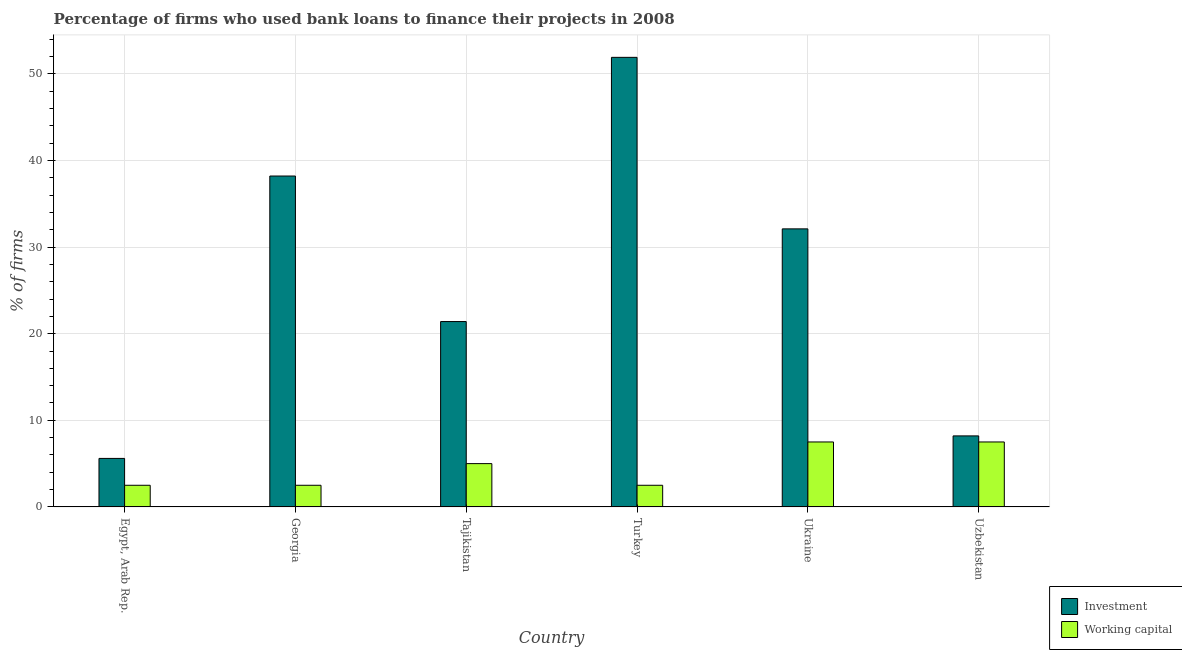What is the label of the 3rd group of bars from the left?
Offer a terse response. Tajikistan. What is the percentage of firms using banks to finance investment in Ukraine?
Your answer should be compact. 32.1. Across all countries, what is the maximum percentage of firms using banks to finance investment?
Give a very brief answer. 51.9. In which country was the percentage of firms using banks to finance working capital maximum?
Offer a very short reply. Ukraine. In which country was the percentage of firms using banks to finance working capital minimum?
Make the answer very short. Egypt, Arab Rep. What is the difference between the percentage of firms using banks to finance investment in Ukraine and that in Uzbekistan?
Your answer should be very brief. 23.9. What is the difference between the percentage of firms using banks to finance working capital in Tajikistan and the percentage of firms using banks to finance investment in Turkey?
Offer a terse response. -46.9. What is the average percentage of firms using banks to finance working capital per country?
Keep it short and to the point. 4.58. What is the difference between the percentage of firms using banks to finance investment and percentage of firms using banks to finance working capital in Uzbekistan?
Keep it short and to the point. 0.7. In how many countries, is the percentage of firms using banks to finance investment greater than 28 %?
Ensure brevity in your answer.  3. What is the difference between the highest and the second highest percentage of firms using banks to finance investment?
Give a very brief answer. 13.7. In how many countries, is the percentage of firms using banks to finance investment greater than the average percentage of firms using banks to finance investment taken over all countries?
Your response must be concise. 3. Is the sum of the percentage of firms using banks to finance working capital in Egypt, Arab Rep. and Turkey greater than the maximum percentage of firms using banks to finance investment across all countries?
Offer a terse response. No. What does the 2nd bar from the left in Uzbekistan represents?
Provide a succinct answer. Working capital. What does the 2nd bar from the right in Uzbekistan represents?
Ensure brevity in your answer.  Investment. Are all the bars in the graph horizontal?
Provide a succinct answer. No. Does the graph contain any zero values?
Make the answer very short. No. How many legend labels are there?
Make the answer very short. 2. What is the title of the graph?
Your response must be concise. Percentage of firms who used bank loans to finance their projects in 2008. Does "Female labourers" appear as one of the legend labels in the graph?
Ensure brevity in your answer.  No. What is the label or title of the X-axis?
Provide a short and direct response. Country. What is the label or title of the Y-axis?
Keep it short and to the point. % of firms. What is the % of firms in Investment in Egypt, Arab Rep.?
Give a very brief answer. 5.6. What is the % of firms in Investment in Georgia?
Your answer should be compact. 38.2. What is the % of firms in Investment in Tajikistan?
Your answer should be compact. 21.4. What is the % of firms in Investment in Turkey?
Ensure brevity in your answer.  51.9. What is the % of firms in Investment in Ukraine?
Offer a very short reply. 32.1. What is the % of firms of Working capital in Uzbekistan?
Provide a succinct answer. 7.5. Across all countries, what is the maximum % of firms in Investment?
Make the answer very short. 51.9. Across all countries, what is the minimum % of firms of Working capital?
Your answer should be compact. 2.5. What is the total % of firms of Investment in the graph?
Your answer should be compact. 157.4. What is the difference between the % of firms of Investment in Egypt, Arab Rep. and that in Georgia?
Your answer should be very brief. -32.6. What is the difference between the % of firms of Working capital in Egypt, Arab Rep. and that in Georgia?
Provide a succinct answer. 0. What is the difference between the % of firms of Investment in Egypt, Arab Rep. and that in Tajikistan?
Give a very brief answer. -15.8. What is the difference between the % of firms of Investment in Egypt, Arab Rep. and that in Turkey?
Give a very brief answer. -46.3. What is the difference between the % of firms in Investment in Egypt, Arab Rep. and that in Ukraine?
Give a very brief answer. -26.5. What is the difference between the % of firms of Working capital in Egypt, Arab Rep. and that in Ukraine?
Keep it short and to the point. -5. What is the difference between the % of firms of Working capital in Georgia and that in Tajikistan?
Offer a very short reply. -2.5. What is the difference between the % of firms in Investment in Georgia and that in Turkey?
Offer a very short reply. -13.7. What is the difference between the % of firms of Working capital in Georgia and that in Turkey?
Your answer should be compact. 0. What is the difference between the % of firms in Investment in Georgia and that in Ukraine?
Your answer should be compact. 6.1. What is the difference between the % of firms in Working capital in Georgia and that in Ukraine?
Offer a very short reply. -5. What is the difference between the % of firms of Investment in Georgia and that in Uzbekistan?
Give a very brief answer. 30. What is the difference between the % of firms in Investment in Tajikistan and that in Turkey?
Offer a terse response. -30.5. What is the difference between the % of firms of Working capital in Tajikistan and that in Turkey?
Ensure brevity in your answer.  2.5. What is the difference between the % of firms of Investment in Tajikistan and that in Ukraine?
Make the answer very short. -10.7. What is the difference between the % of firms of Working capital in Tajikistan and that in Uzbekistan?
Provide a succinct answer. -2.5. What is the difference between the % of firms of Investment in Turkey and that in Ukraine?
Your response must be concise. 19.8. What is the difference between the % of firms of Working capital in Turkey and that in Ukraine?
Your answer should be compact. -5. What is the difference between the % of firms in Investment in Turkey and that in Uzbekistan?
Keep it short and to the point. 43.7. What is the difference between the % of firms of Working capital in Turkey and that in Uzbekistan?
Your answer should be compact. -5. What is the difference between the % of firms in Investment in Ukraine and that in Uzbekistan?
Keep it short and to the point. 23.9. What is the difference between the % of firms in Investment in Egypt, Arab Rep. and the % of firms in Working capital in Georgia?
Offer a terse response. 3.1. What is the difference between the % of firms in Investment in Egypt, Arab Rep. and the % of firms in Working capital in Ukraine?
Give a very brief answer. -1.9. What is the difference between the % of firms of Investment in Egypt, Arab Rep. and the % of firms of Working capital in Uzbekistan?
Your answer should be very brief. -1.9. What is the difference between the % of firms in Investment in Georgia and the % of firms in Working capital in Tajikistan?
Ensure brevity in your answer.  33.2. What is the difference between the % of firms in Investment in Georgia and the % of firms in Working capital in Turkey?
Your answer should be very brief. 35.7. What is the difference between the % of firms of Investment in Georgia and the % of firms of Working capital in Ukraine?
Make the answer very short. 30.7. What is the difference between the % of firms of Investment in Georgia and the % of firms of Working capital in Uzbekistan?
Your answer should be compact. 30.7. What is the difference between the % of firms of Investment in Turkey and the % of firms of Working capital in Ukraine?
Give a very brief answer. 44.4. What is the difference between the % of firms in Investment in Turkey and the % of firms in Working capital in Uzbekistan?
Provide a short and direct response. 44.4. What is the difference between the % of firms in Investment in Ukraine and the % of firms in Working capital in Uzbekistan?
Ensure brevity in your answer.  24.6. What is the average % of firms of Investment per country?
Your answer should be compact. 26.23. What is the average % of firms in Working capital per country?
Provide a succinct answer. 4.58. What is the difference between the % of firms in Investment and % of firms in Working capital in Egypt, Arab Rep.?
Your response must be concise. 3.1. What is the difference between the % of firms of Investment and % of firms of Working capital in Georgia?
Your answer should be very brief. 35.7. What is the difference between the % of firms of Investment and % of firms of Working capital in Tajikistan?
Your answer should be compact. 16.4. What is the difference between the % of firms of Investment and % of firms of Working capital in Turkey?
Offer a terse response. 49.4. What is the difference between the % of firms of Investment and % of firms of Working capital in Ukraine?
Your response must be concise. 24.6. What is the ratio of the % of firms of Investment in Egypt, Arab Rep. to that in Georgia?
Make the answer very short. 0.15. What is the ratio of the % of firms in Working capital in Egypt, Arab Rep. to that in Georgia?
Provide a short and direct response. 1. What is the ratio of the % of firms in Investment in Egypt, Arab Rep. to that in Tajikistan?
Your response must be concise. 0.26. What is the ratio of the % of firms in Working capital in Egypt, Arab Rep. to that in Tajikistan?
Your answer should be very brief. 0.5. What is the ratio of the % of firms in Investment in Egypt, Arab Rep. to that in Turkey?
Your answer should be very brief. 0.11. What is the ratio of the % of firms of Working capital in Egypt, Arab Rep. to that in Turkey?
Your answer should be very brief. 1. What is the ratio of the % of firms of Investment in Egypt, Arab Rep. to that in Ukraine?
Provide a succinct answer. 0.17. What is the ratio of the % of firms of Working capital in Egypt, Arab Rep. to that in Ukraine?
Offer a terse response. 0.33. What is the ratio of the % of firms of Investment in Egypt, Arab Rep. to that in Uzbekistan?
Make the answer very short. 0.68. What is the ratio of the % of firms in Investment in Georgia to that in Tajikistan?
Your answer should be very brief. 1.78. What is the ratio of the % of firms in Investment in Georgia to that in Turkey?
Give a very brief answer. 0.74. What is the ratio of the % of firms in Investment in Georgia to that in Ukraine?
Make the answer very short. 1.19. What is the ratio of the % of firms of Working capital in Georgia to that in Ukraine?
Give a very brief answer. 0.33. What is the ratio of the % of firms in Investment in Georgia to that in Uzbekistan?
Your answer should be compact. 4.66. What is the ratio of the % of firms in Investment in Tajikistan to that in Turkey?
Ensure brevity in your answer.  0.41. What is the ratio of the % of firms of Working capital in Tajikistan to that in Turkey?
Give a very brief answer. 2. What is the ratio of the % of firms in Investment in Tajikistan to that in Uzbekistan?
Your answer should be compact. 2.61. What is the ratio of the % of firms of Working capital in Tajikistan to that in Uzbekistan?
Your response must be concise. 0.67. What is the ratio of the % of firms of Investment in Turkey to that in Ukraine?
Your answer should be very brief. 1.62. What is the ratio of the % of firms in Working capital in Turkey to that in Ukraine?
Provide a short and direct response. 0.33. What is the ratio of the % of firms in Investment in Turkey to that in Uzbekistan?
Make the answer very short. 6.33. What is the ratio of the % of firms of Working capital in Turkey to that in Uzbekistan?
Keep it short and to the point. 0.33. What is the ratio of the % of firms in Investment in Ukraine to that in Uzbekistan?
Provide a short and direct response. 3.91. What is the ratio of the % of firms of Working capital in Ukraine to that in Uzbekistan?
Provide a short and direct response. 1. What is the difference between the highest and the lowest % of firms in Investment?
Provide a short and direct response. 46.3. 